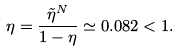Convert formula to latex. <formula><loc_0><loc_0><loc_500><loc_500>\eta = \frac { \tilde { \eta } ^ { N } } { 1 - \eta } \simeq 0 . 0 8 2 < 1 .</formula> 